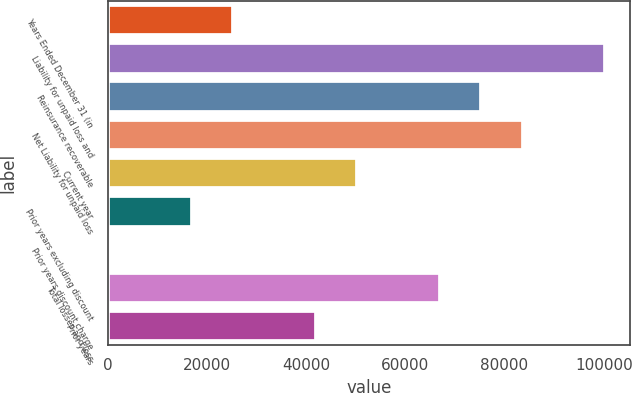<chart> <loc_0><loc_0><loc_500><loc_500><bar_chart><fcel>Years Ended December 31 (in<fcel>Liability for unpaid loss and<fcel>Reinsurance recoverable<fcel>Net Liability for unpaid loss<fcel>Current year<fcel>Prior years excluding discount<fcel>Prior years discount charge<fcel>Total losses and loss<fcel>Prior years<nl><fcel>25268.1<fcel>100316<fcel>75300.3<fcel>83639<fcel>50284.2<fcel>16929.4<fcel>252<fcel>66961.6<fcel>41945.5<nl></chart> 